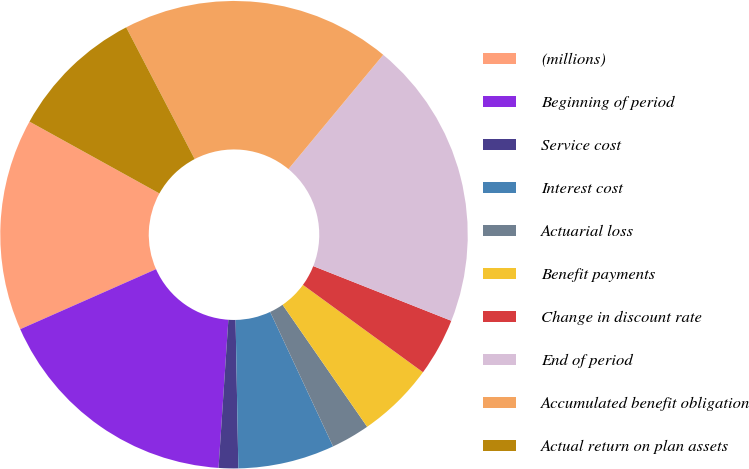Convert chart. <chart><loc_0><loc_0><loc_500><loc_500><pie_chart><fcel>(millions)<fcel>Beginning of period<fcel>Service cost<fcel>Interest cost<fcel>Actuarial loss<fcel>Benefit payments<fcel>Change in discount rate<fcel>End of period<fcel>Accumulated benefit obligation<fcel>Actual return on plan assets<nl><fcel>14.66%<fcel>17.32%<fcel>1.35%<fcel>6.67%<fcel>2.68%<fcel>5.34%<fcel>4.01%<fcel>19.98%<fcel>18.65%<fcel>9.33%<nl></chart> 